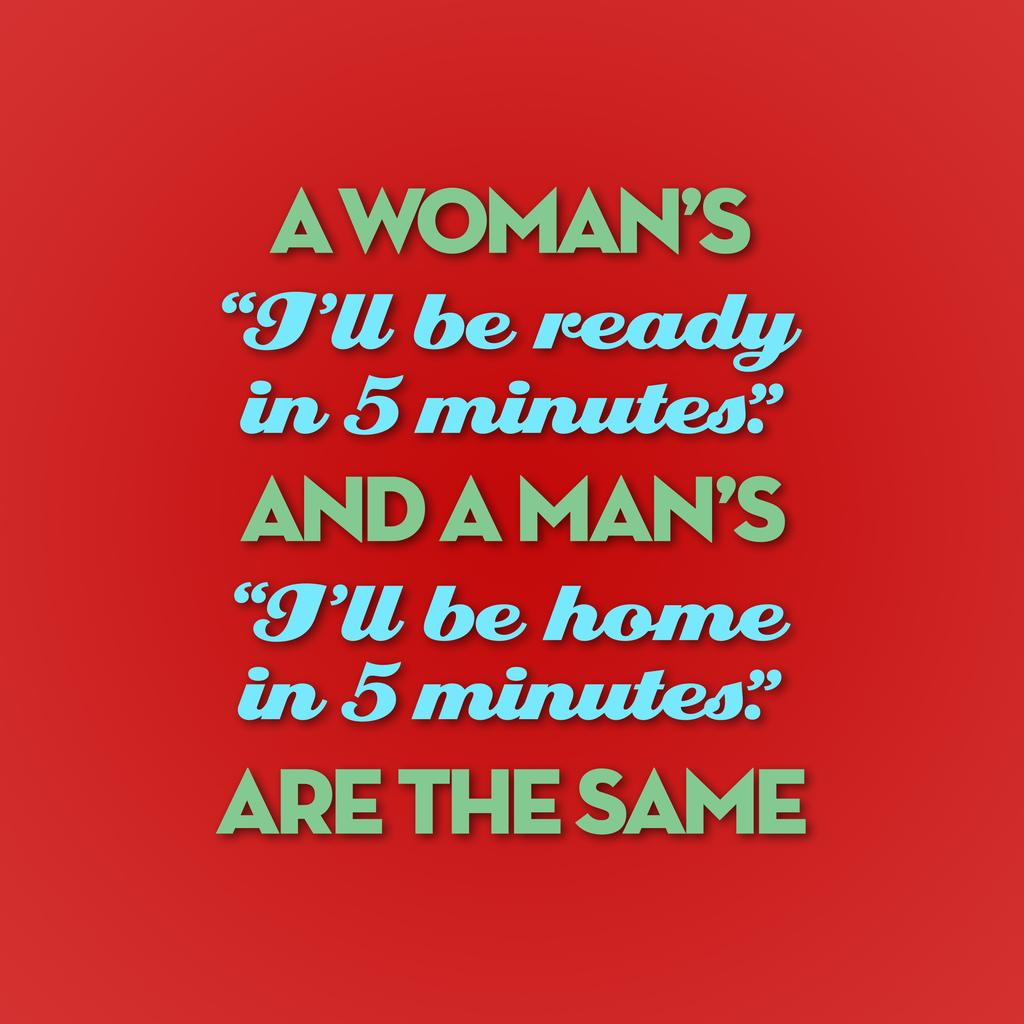<image>
Create a compact narrative representing the image presented. a quote with a red background with 5 minutes on it 